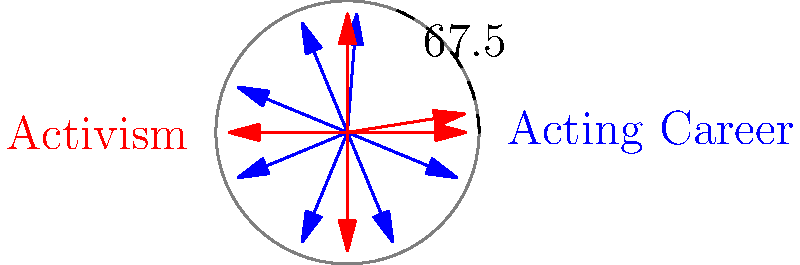On the radial chart depicting George Takei's acting career (blue) and activism (red) timelines, what is the approximate angle between the first documented instances of his acting career and his activism? To solve this question, we need to follow these steps:

1. Identify the starting points of George Takei's acting career and activism:
   - Acting career: 1959 (first blue arrow)
   - Activism: 1942 (first red arrow)

2. Calculate the years elapsed since 1940 (the chart's starting point):
   - Acting: 1959 - 1940 = 19 years
   - Activism: 1942 - 1940 = 2 years

3. Convert years to angles on the radial chart:
   - The chart represents 80 years (1940 to 2020) in a full circle (360°)
   - Angle for acting: (19 / 80) * 360° = 85.5°
   - Angle for activism: (2 / 80) * 360° = 9°

4. Calculate the difference between these angles:
   85.5° - 9° = 76.5°

5. The chart shows an approximate angle of 67.5°, which is close to our calculated value. The slight difference can be attributed to the visual approximation in the chart.

Therefore, the approximate angle between the first documented instances of George Takei's acting career and his activism is 67.5°.
Answer: 67.5° 